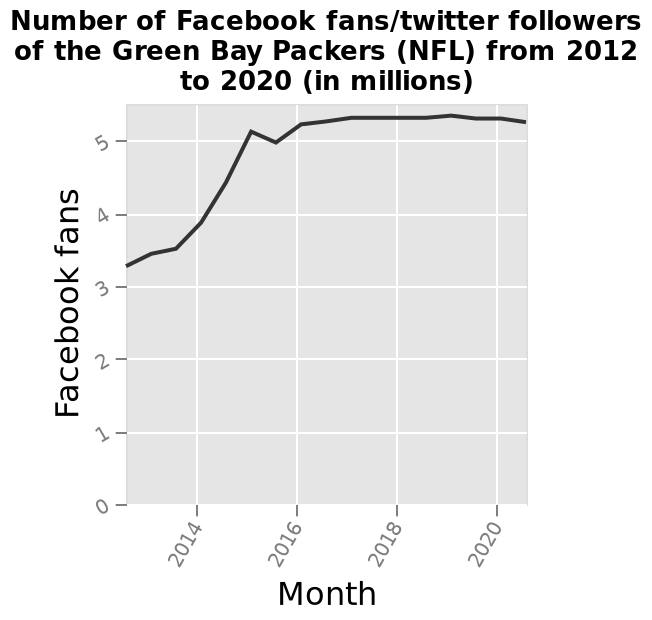<image>
What does the y-axis represent in the line graph? The y-axis in the line graph represents the number of Facebook fans. Describe the following image in detail This line graph is titled Number of Facebook fans/twitter followers of the Green Bay Packers (NFL) from 2012 to 2020 (in millions). The x-axis shows Month while the y-axis plots Facebook fans.  What happened to the number of fans from 2012 to 2013?  The number of fans increased steadily during that period. 